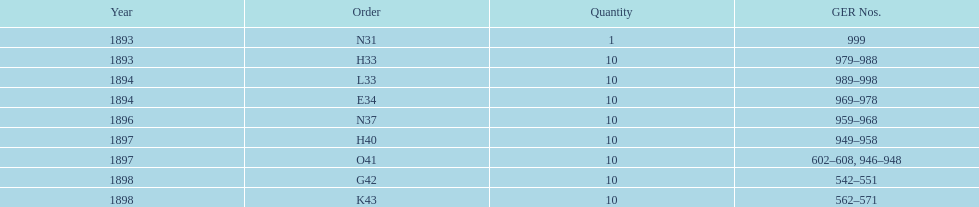What is the order of the last year listed? K43. 